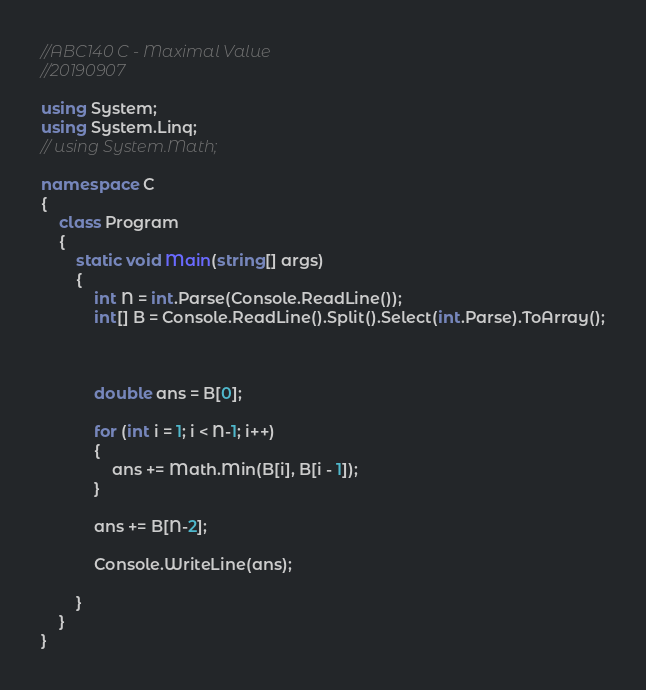<code> <loc_0><loc_0><loc_500><loc_500><_C#_>//ABC140 C - Maximal Value
//20190907

using System;
using System.Linq;
// using System.Math;

namespace C
{
    class Program
    {
        static void Main(string[] args)
        {
            int N = int.Parse(Console.ReadLine());
            int[] B = Console.ReadLine().Split().Select(int.Parse).ToArray();



            double ans = B[0];

            for (int i = 1; i < N-1; i++)
            {
                ans += Math.Min(B[i], B[i - 1]);
            }
            
            ans += B[N-2];

            Console.WriteLine(ans);

        }
    }
}
</code> 